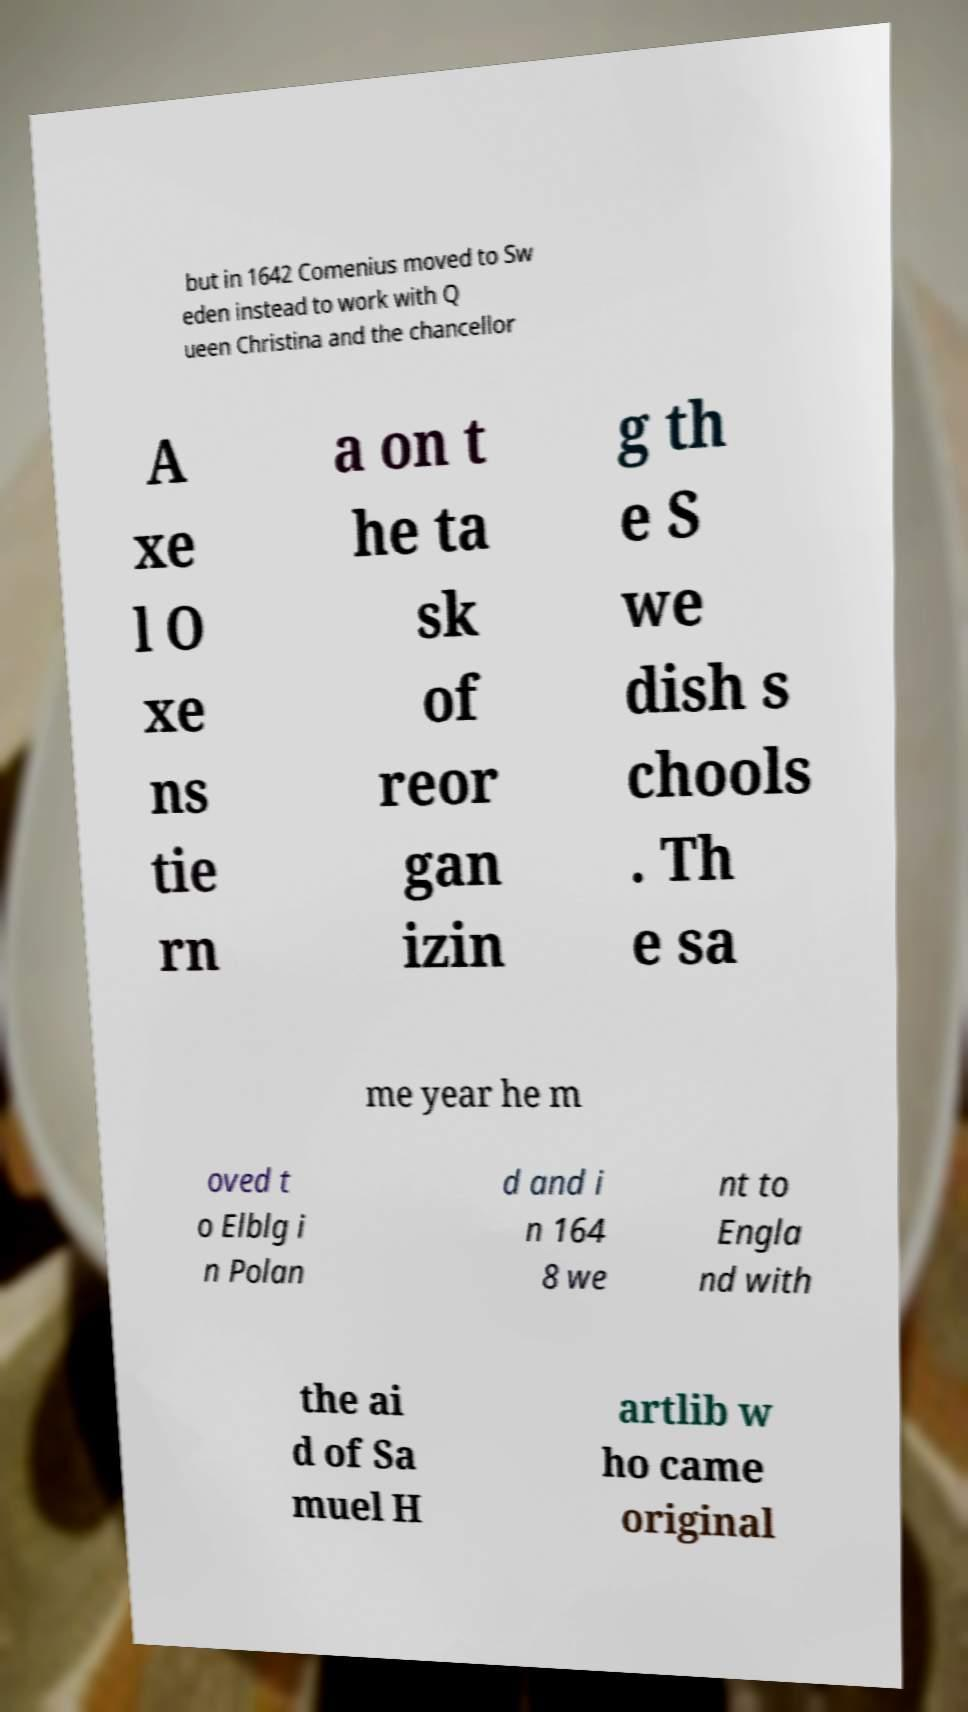Please identify and transcribe the text found in this image. but in 1642 Comenius moved to Sw eden instead to work with Q ueen Christina and the chancellor A xe l O xe ns tie rn a on t he ta sk of reor gan izin g th e S we dish s chools . Th e sa me year he m oved t o Elblg i n Polan d and i n 164 8 we nt to Engla nd with the ai d of Sa muel H artlib w ho came original 